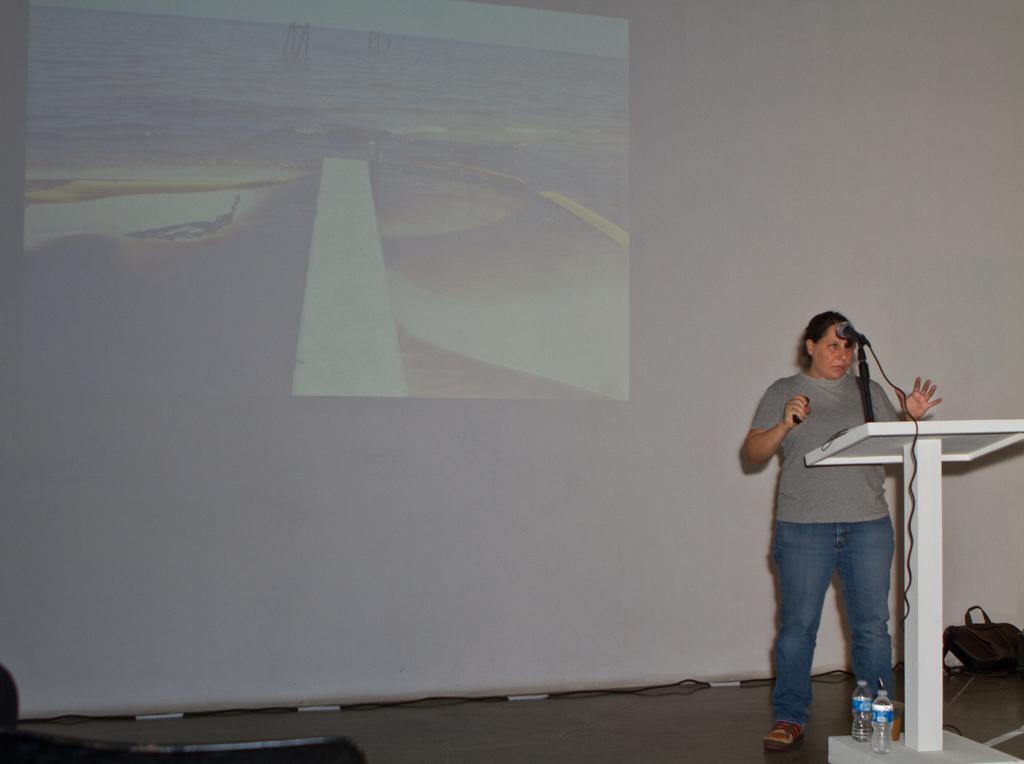Can you describe this image briefly? This image consists of a woman standing near the podium and talking in the mic. In the background, we can see a projector screen. At the bottom, there is a dais. There are two water bottles near the podium. 